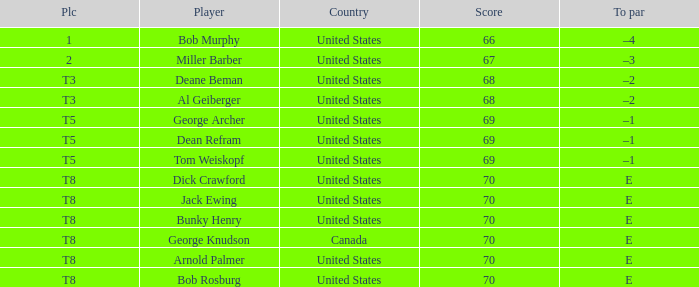Which country is George Archer from? United States. 